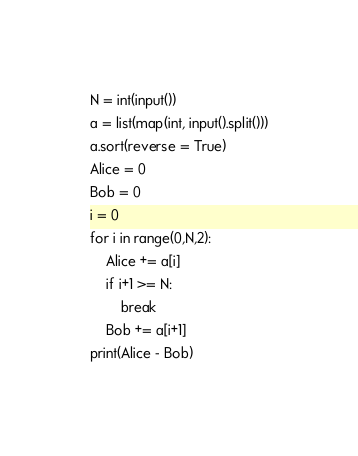Convert code to text. <code><loc_0><loc_0><loc_500><loc_500><_Python_>N = int(input())
a = list(map(int, input().split()))
a.sort(reverse = True)
Alice = 0
Bob = 0
i = 0
for i in range(0,N,2):
    Alice += a[i]
    if i+1 >= N:
        break
    Bob += a[i+1]
print(Alice - Bob)</code> 